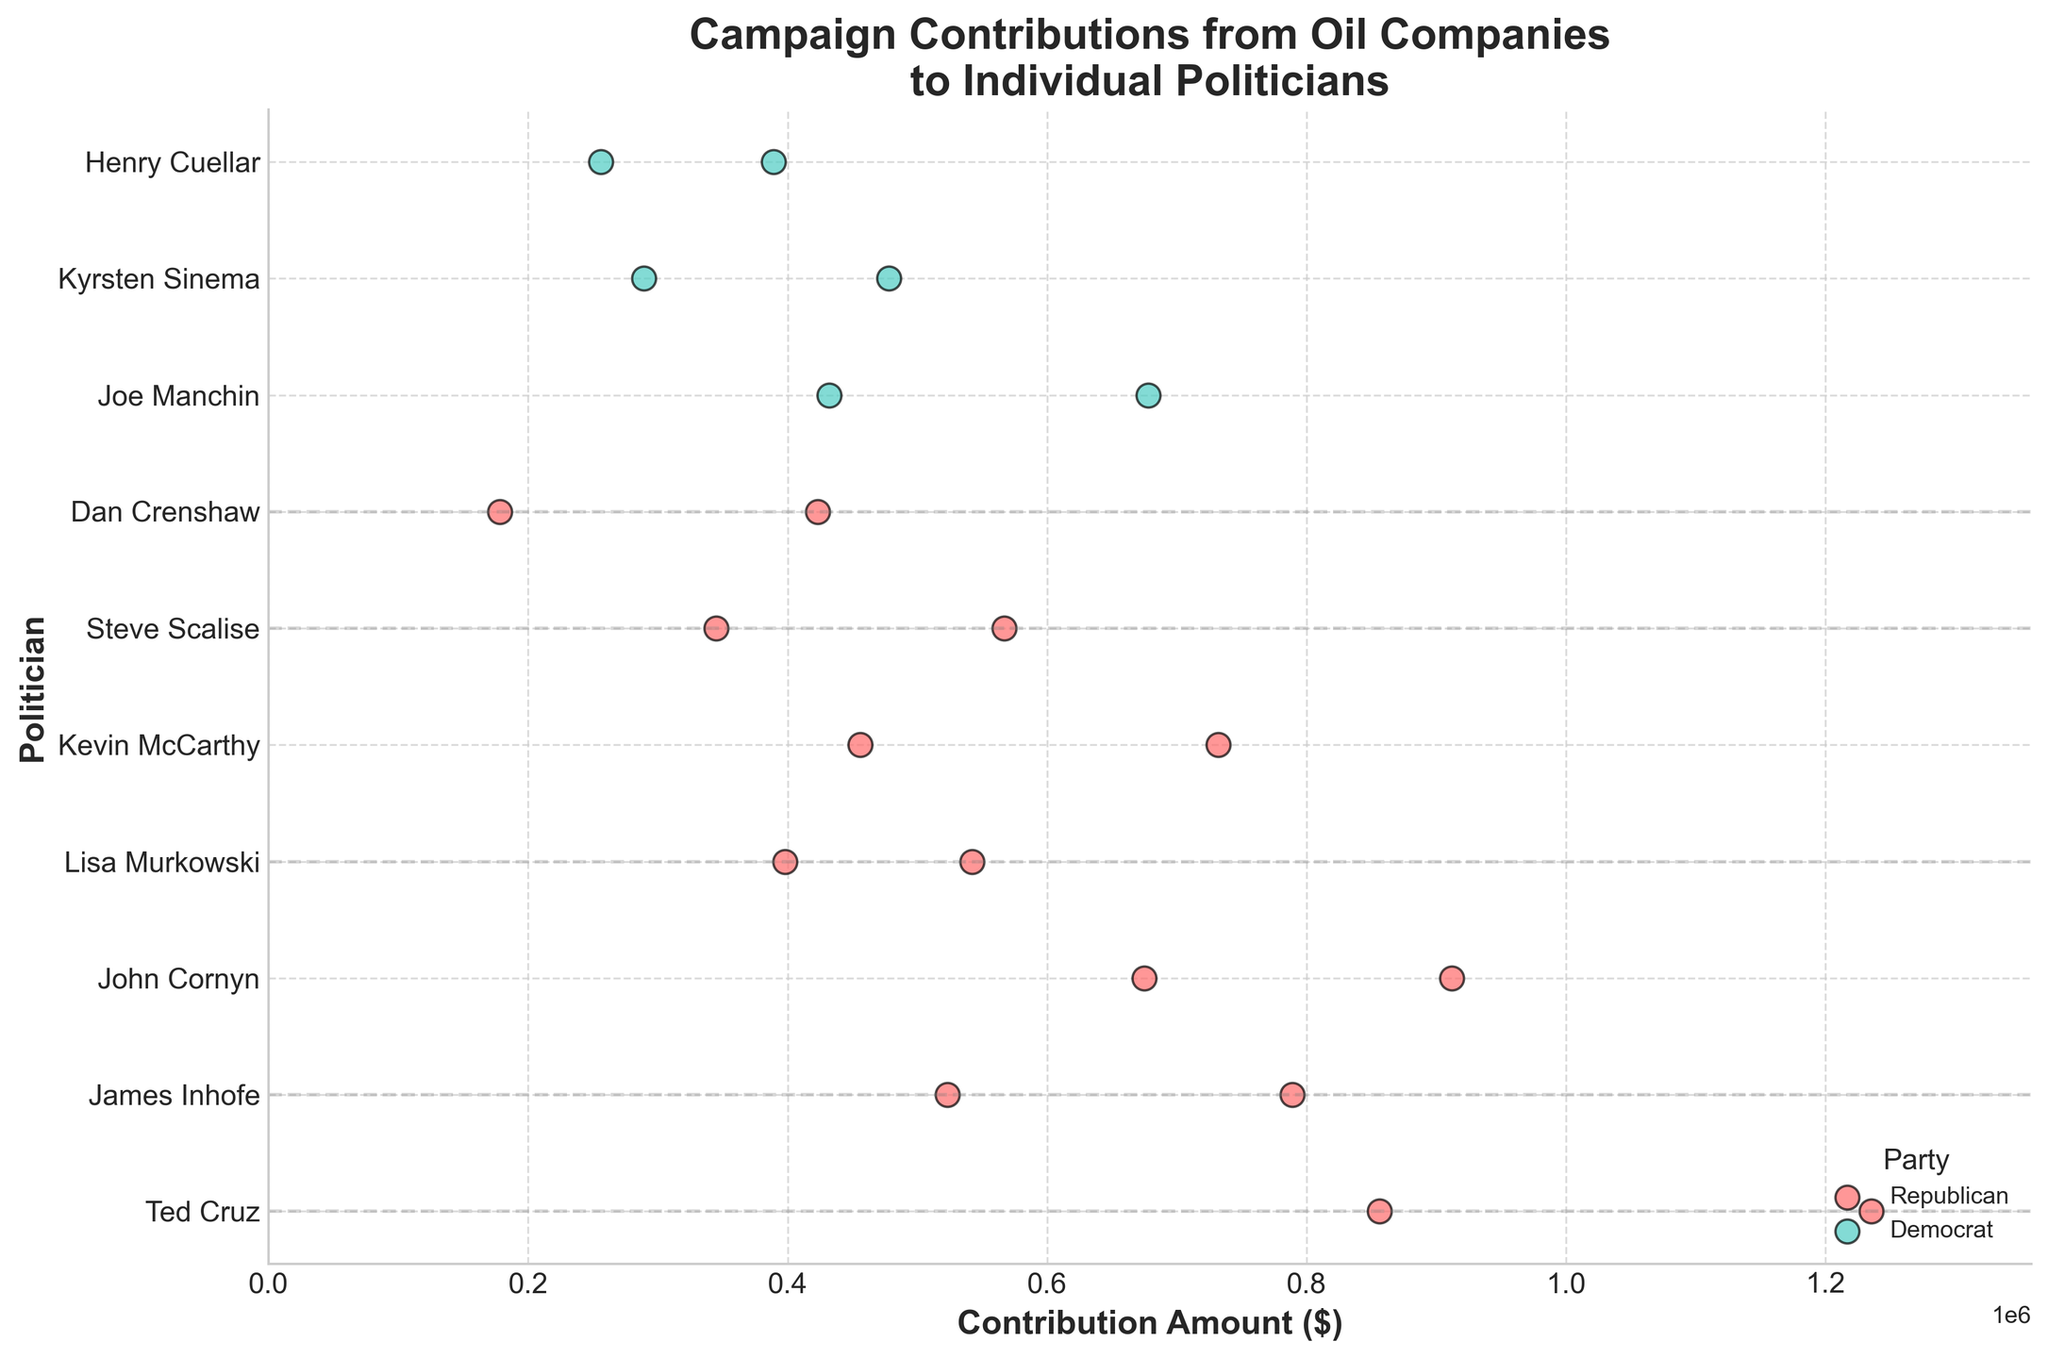How many politicians are represented in the figure? Count the unique names of the politicians along the y-axis. There are 10 unique politicians.
Answer: 10 What is the title of the figure? The title of the figure is displayed at the top.
Answer: Campaign Contributions from Oil Companies to Individual Politicians Which politician received the highest contribution amount? Identify the highest point on the x-axis and trace it to the corresponding politician on the y-axis. Ted Cruz received the highest contribution amount.
Answer: Ted Cruz What is the difference in oil contributions between Ted Cruz in 2020 and 2016? Locate Ted Cruz's data points for 2016 and 2020, then subtract the 2016 contribution from the 2020 contribution. The difference is 1235000 - 856000 = 379000.
Answer: 379000 How do contributions to Joe Manchin in 2018 compare to 2022? Compare the x-axis values for Joe Manchin in 2018 and 2022. Contributions in 2022 are higher.
Answer: Higher in 2022 Which party received more contributions overall? Visualize the spread and density of the contribution points for each party and sum them. Republicans received more contributions overall.
Answer: Republicans What is the average contribution amount received by Kevin McCarthy across all election cycles? Sum the contributions received and divide by the number of cycles. (456000 + 732000) / 2 = 594000.
Answer: 594000 Which election cycle shows the highest total contribution from oil companies? Sum the contributions for each election cycle and identify the highest total. The 2020 election cycle shows the highest total.
Answer: 2020 Are there any Democrats who received more contributions than any Republican? Compare the highest contributions received by any Democrat with the contributions received by Republicans. No Democrat received more contributions than the top Republican contributors.
Answer: No What is the range of contributions received by Steve Scalise across all election cycles? Identify the minimum and maximum contributions received (345000 in 2016 and 567000 in 2020). The range is 567000 - 345000 = 222000.
Answer: 222000 